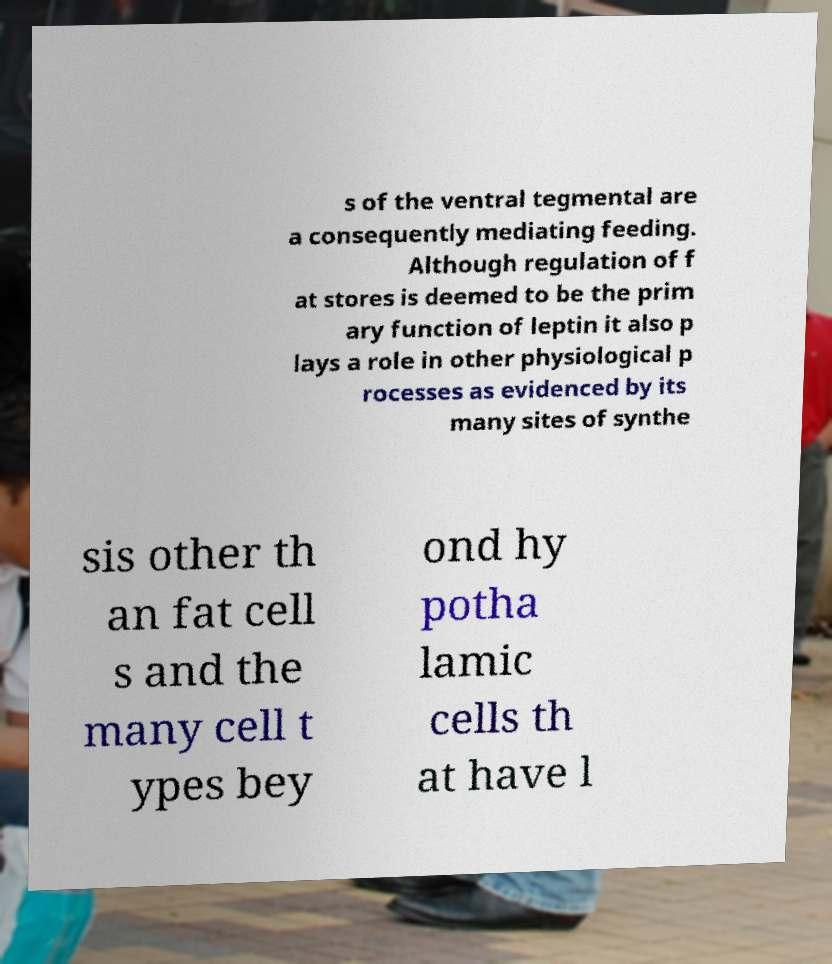Please read and relay the text visible in this image. What does it say? s of the ventral tegmental are a consequently mediating feeding. Although regulation of f at stores is deemed to be the prim ary function of leptin it also p lays a role in other physiological p rocesses as evidenced by its many sites of synthe sis other th an fat cell s and the many cell t ypes bey ond hy potha lamic cells th at have l 